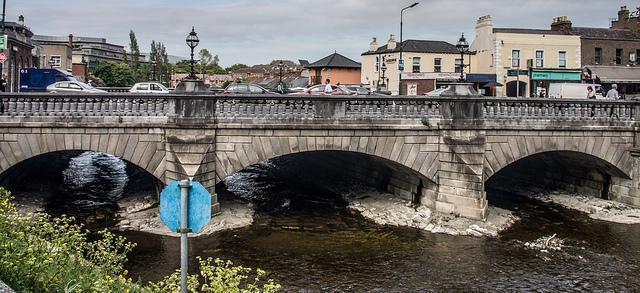What kind of river channel it is?
Answer the question by selecting the correct answer among the 4 following choices and explain your choice with a short sentence. The answer should be formatted with the following format: `Answer: choice
Rationale: rationale.`
Options: Sea, canal, pond, river. Answer: canal.
Rationale: The river is a canal. 